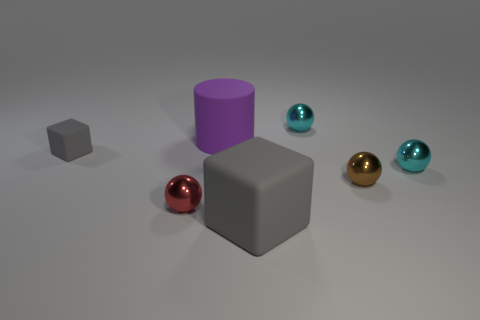What is the material of the small brown sphere?
Provide a succinct answer. Metal. Is the color of the tiny matte cube the same as the large matte thing that is on the right side of the big cylinder?
Give a very brief answer. Yes. How many balls are red shiny things or tiny brown objects?
Your response must be concise. 2. The big matte object to the right of the large purple matte cylinder is what color?
Offer a terse response. Gray. What is the shape of the small matte thing that is the same color as the large block?
Your answer should be very brief. Cube. What number of gray things are the same size as the cylinder?
Provide a succinct answer. 1. There is a big thing behind the small red metal object; is it the same shape as the gray matte thing behind the large gray matte cube?
Your answer should be very brief. No. What is the material of the tiny cyan object that is behind the gray block behind the small sphere that is on the left side of the purple object?
Provide a succinct answer. Metal. What shape is the gray object that is the same size as the purple cylinder?
Ensure brevity in your answer.  Cube. Are there any rubber objects of the same color as the big block?
Provide a short and direct response. Yes. 